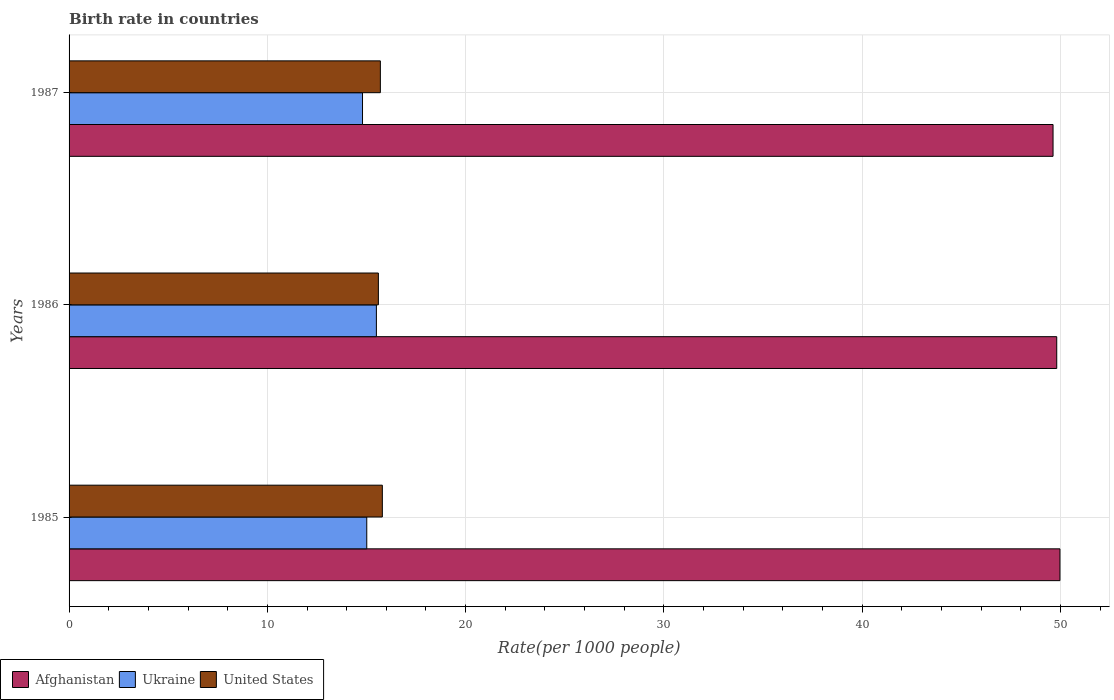How many different coloured bars are there?
Give a very brief answer. 3. Are the number of bars per tick equal to the number of legend labels?
Make the answer very short. Yes. Are the number of bars on each tick of the Y-axis equal?
Provide a succinct answer. Yes. How many bars are there on the 1st tick from the top?
Give a very brief answer. 3. How many bars are there on the 1st tick from the bottom?
Offer a terse response. 3. Across all years, what is the maximum birth rate in Afghanistan?
Your response must be concise. 49.98. In which year was the birth rate in Ukraine minimum?
Make the answer very short. 1987. What is the total birth rate in United States in the graph?
Your answer should be very brief. 47.1. What is the difference between the birth rate in Ukraine in 1985 and that in 1987?
Your answer should be compact. 0.21. What is the difference between the birth rate in Afghanistan in 1987 and the birth rate in United States in 1985?
Your answer should be very brief. 33.83. What is the average birth rate in United States per year?
Keep it short and to the point. 15.7. In the year 1985, what is the difference between the birth rate in United States and birth rate in Afghanistan?
Offer a terse response. -34.17. In how many years, is the birth rate in United States greater than 42 ?
Provide a succinct answer. 0. What is the ratio of the birth rate in United States in 1986 to that in 1987?
Keep it short and to the point. 0.99. What is the difference between the highest and the second highest birth rate in Ukraine?
Make the answer very short. 0.49. What is the difference between the highest and the lowest birth rate in United States?
Your response must be concise. 0.2. What does the 1st bar from the top in 1986 represents?
Ensure brevity in your answer.  United States. What does the 1st bar from the bottom in 1985 represents?
Provide a succinct answer. Afghanistan. Is it the case that in every year, the sum of the birth rate in Ukraine and birth rate in Afghanistan is greater than the birth rate in United States?
Your response must be concise. Yes. How many bars are there?
Offer a very short reply. 9. Are all the bars in the graph horizontal?
Give a very brief answer. Yes. What is the difference between two consecutive major ticks on the X-axis?
Offer a very short reply. 10. Are the values on the major ticks of X-axis written in scientific E-notation?
Offer a very short reply. No. Does the graph contain grids?
Offer a terse response. Yes. Where does the legend appear in the graph?
Give a very brief answer. Bottom left. How many legend labels are there?
Provide a succinct answer. 3. What is the title of the graph?
Make the answer very short. Birth rate in countries. What is the label or title of the X-axis?
Ensure brevity in your answer.  Rate(per 1000 people). What is the Rate(per 1000 people) in Afghanistan in 1985?
Your answer should be compact. 49.98. What is the Rate(per 1000 people) of Ukraine in 1985?
Give a very brief answer. 15.01. What is the Rate(per 1000 people) in United States in 1985?
Your answer should be very brief. 15.8. What is the Rate(per 1000 people) in Afghanistan in 1986?
Make the answer very short. 49.81. What is the Rate(per 1000 people) of Afghanistan in 1987?
Offer a terse response. 49.63. What is the Rate(per 1000 people) in Ukraine in 1987?
Your answer should be compact. 14.8. What is the Rate(per 1000 people) of United States in 1987?
Make the answer very short. 15.7. Across all years, what is the maximum Rate(per 1000 people) in Afghanistan?
Your answer should be very brief. 49.98. Across all years, what is the maximum Rate(per 1000 people) of United States?
Offer a terse response. 15.8. Across all years, what is the minimum Rate(per 1000 people) in Afghanistan?
Provide a succinct answer. 49.63. Across all years, what is the minimum Rate(per 1000 people) of Ukraine?
Make the answer very short. 14.8. What is the total Rate(per 1000 people) in Afghanistan in the graph?
Give a very brief answer. 149.41. What is the total Rate(per 1000 people) of Ukraine in the graph?
Ensure brevity in your answer.  45.31. What is the total Rate(per 1000 people) in United States in the graph?
Ensure brevity in your answer.  47.1. What is the difference between the Rate(per 1000 people) in Afghanistan in 1985 and that in 1986?
Your response must be concise. 0.16. What is the difference between the Rate(per 1000 people) of Ukraine in 1985 and that in 1986?
Keep it short and to the point. -0.49. What is the difference between the Rate(per 1000 people) of United States in 1985 and that in 1986?
Provide a succinct answer. 0.2. What is the difference between the Rate(per 1000 people) of Afghanistan in 1985 and that in 1987?
Keep it short and to the point. 0.35. What is the difference between the Rate(per 1000 people) of Ukraine in 1985 and that in 1987?
Ensure brevity in your answer.  0.21. What is the difference between the Rate(per 1000 people) in United States in 1985 and that in 1987?
Offer a terse response. 0.1. What is the difference between the Rate(per 1000 people) in Afghanistan in 1986 and that in 1987?
Make the answer very short. 0.19. What is the difference between the Rate(per 1000 people) of Ukraine in 1986 and that in 1987?
Offer a very short reply. 0.7. What is the difference between the Rate(per 1000 people) in United States in 1986 and that in 1987?
Offer a very short reply. -0.1. What is the difference between the Rate(per 1000 people) of Afghanistan in 1985 and the Rate(per 1000 people) of Ukraine in 1986?
Offer a terse response. 34.48. What is the difference between the Rate(per 1000 people) in Afghanistan in 1985 and the Rate(per 1000 people) in United States in 1986?
Keep it short and to the point. 34.38. What is the difference between the Rate(per 1000 people) in Ukraine in 1985 and the Rate(per 1000 people) in United States in 1986?
Make the answer very short. -0.59. What is the difference between the Rate(per 1000 people) of Afghanistan in 1985 and the Rate(per 1000 people) of Ukraine in 1987?
Provide a short and direct response. 35.17. What is the difference between the Rate(per 1000 people) of Afghanistan in 1985 and the Rate(per 1000 people) of United States in 1987?
Offer a very short reply. 34.27. What is the difference between the Rate(per 1000 people) in Ukraine in 1985 and the Rate(per 1000 people) in United States in 1987?
Ensure brevity in your answer.  -0.69. What is the difference between the Rate(per 1000 people) of Afghanistan in 1986 and the Rate(per 1000 people) of Ukraine in 1987?
Offer a terse response. 35.01. What is the difference between the Rate(per 1000 people) in Afghanistan in 1986 and the Rate(per 1000 people) in United States in 1987?
Provide a succinct answer. 34.11. What is the average Rate(per 1000 people) of Afghanistan per year?
Your answer should be compact. 49.8. What is the average Rate(per 1000 people) in Ukraine per year?
Provide a short and direct response. 15.1. In the year 1985, what is the difference between the Rate(per 1000 people) of Afghanistan and Rate(per 1000 people) of Ukraine?
Your response must be concise. 34.96. In the year 1985, what is the difference between the Rate(per 1000 people) in Afghanistan and Rate(per 1000 people) in United States?
Ensure brevity in your answer.  34.17. In the year 1985, what is the difference between the Rate(per 1000 people) in Ukraine and Rate(per 1000 people) in United States?
Offer a very short reply. -0.79. In the year 1986, what is the difference between the Rate(per 1000 people) of Afghanistan and Rate(per 1000 people) of Ukraine?
Your response must be concise. 34.31. In the year 1986, what is the difference between the Rate(per 1000 people) of Afghanistan and Rate(per 1000 people) of United States?
Make the answer very short. 34.21. In the year 1987, what is the difference between the Rate(per 1000 people) of Afghanistan and Rate(per 1000 people) of Ukraine?
Give a very brief answer. 34.83. In the year 1987, what is the difference between the Rate(per 1000 people) in Afghanistan and Rate(per 1000 people) in United States?
Your answer should be compact. 33.93. What is the ratio of the Rate(per 1000 people) of Ukraine in 1985 to that in 1986?
Provide a short and direct response. 0.97. What is the ratio of the Rate(per 1000 people) of United States in 1985 to that in 1986?
Ensure brevity in your answer.  1.01. What is the ratio of the Rate(per 1000 people) of Afghanistan in 1985 to that in 1987?
Your response must be concise. 1.01. What is the ratio of the Rate(per 1000 people) in Ukraine in 1985 to that in 1987?
Your answer should be very brief. 1.01. What is the ratio of the Rate(per 1000 people) of United States in 1985 to that in 1987?
Provide a short and direct response. 1.01. What is the ratio of the Rate(per 1000 people) of Afghanistan in 1986 to that in 1987?
Provide a short and direct response. 1. What is the ratio of the Rate(per 1000 people) in Ukraine in 1986 to that in 1987?
Offer a terse response. 1.05. What is the ratio of the Rate(per 1000 people) in United States in 1986 to that in 1987?
Ensure brevity in your answer.  0.99. What is the difference between the highest and the second highest Rate(per 1000 people) of Afghanistan?
Provide a succinct answer. 0.16. What is the difference between the highest and the second highest Rate(per 1000 people) of Ukraine?
Give a very brief answer. 0.49. What is the difference between the highest and the lowest Rate(per 1000 people) of Afghanistan?
Offer a very short reply. 0.35. What is the difference between the highest and the lowest Rate(per 1000 people) of United States?
Ensure brevity in your answer.  0.2. 